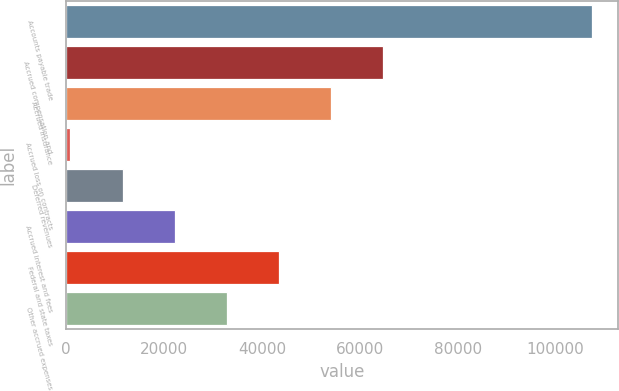Convert chart. <chart><loc_0><loc_0><loc_500><loc_500><bar_chart><fcel>Accounts payable trade<fcel>Accrued compensation and<fcel>Accrued insurance<fcel>Accrued loss on contracts<fcel>Deferred revenues<fcel>Accrued interest and fees<fcel>Federal and state taxes<fcel>Other accrued expenses<nl><fcel>107484<fcel>64840.8<fcel>54180<fcel>876<fcel>11536.8<fcel>22197.6<fcel>43519.2<fcel>32858.4<nl></chart> 